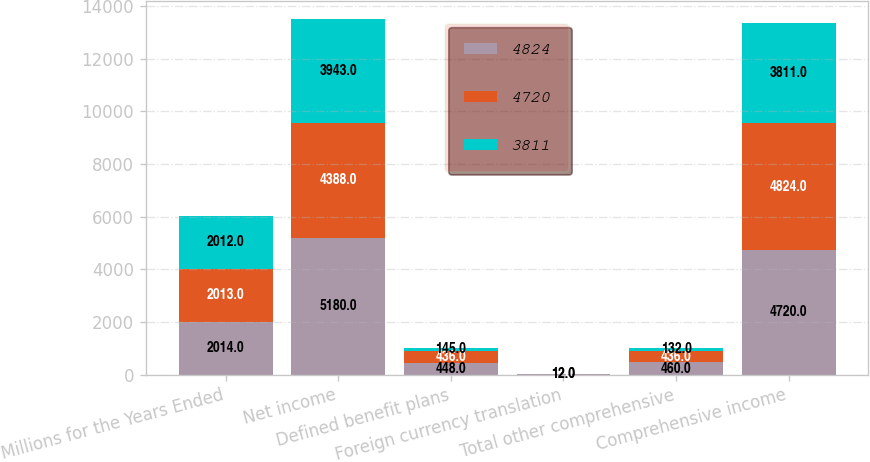Convert chart. <chart><loc_0><loc_0><loc_500><loc_500><stacked_bar_chart><ecel><fcel>Millions for the Years Ended<fcel>Net income<fcel>Defined benefit plans<fcel>Foreign currency translation<fcel>Total other comprehensive<fcel>Comprehensive income<nl><fcel>4824<fcel>2014<fcel>5180<fcel>448<fcel>12<fcel>460<fcel>4720<nl><fcel>4720<fcel>2013<fcel>4388<fcel>436<fcel>1<fcel>436<fcel>4824<nl><fcel>3811<fcel>2012<fcel>3943<fcel>145<fcel>12<fcel>132<fcel>3811<nl></chart> 